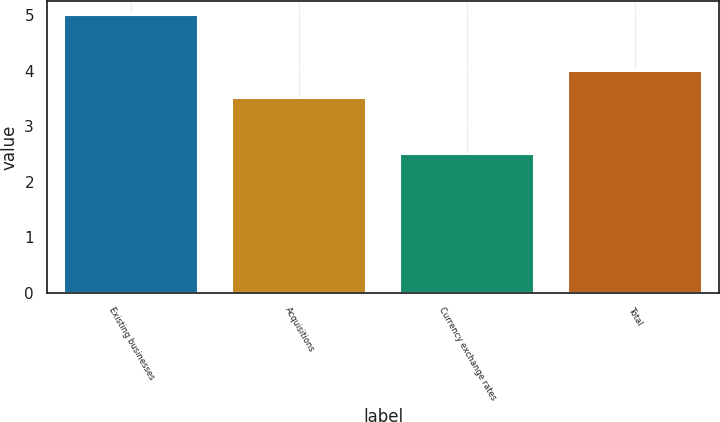<chart> <loc_0><loc_0><loc_500><loc_500><bar_chart><fcel>Existing businesses<fcel>Acquisitions<fcel>Currency exchange rates<fcel>Total<nl><fcel>5<fcel>3.5<fcel>2.5<fcel>4<nl></chart> 